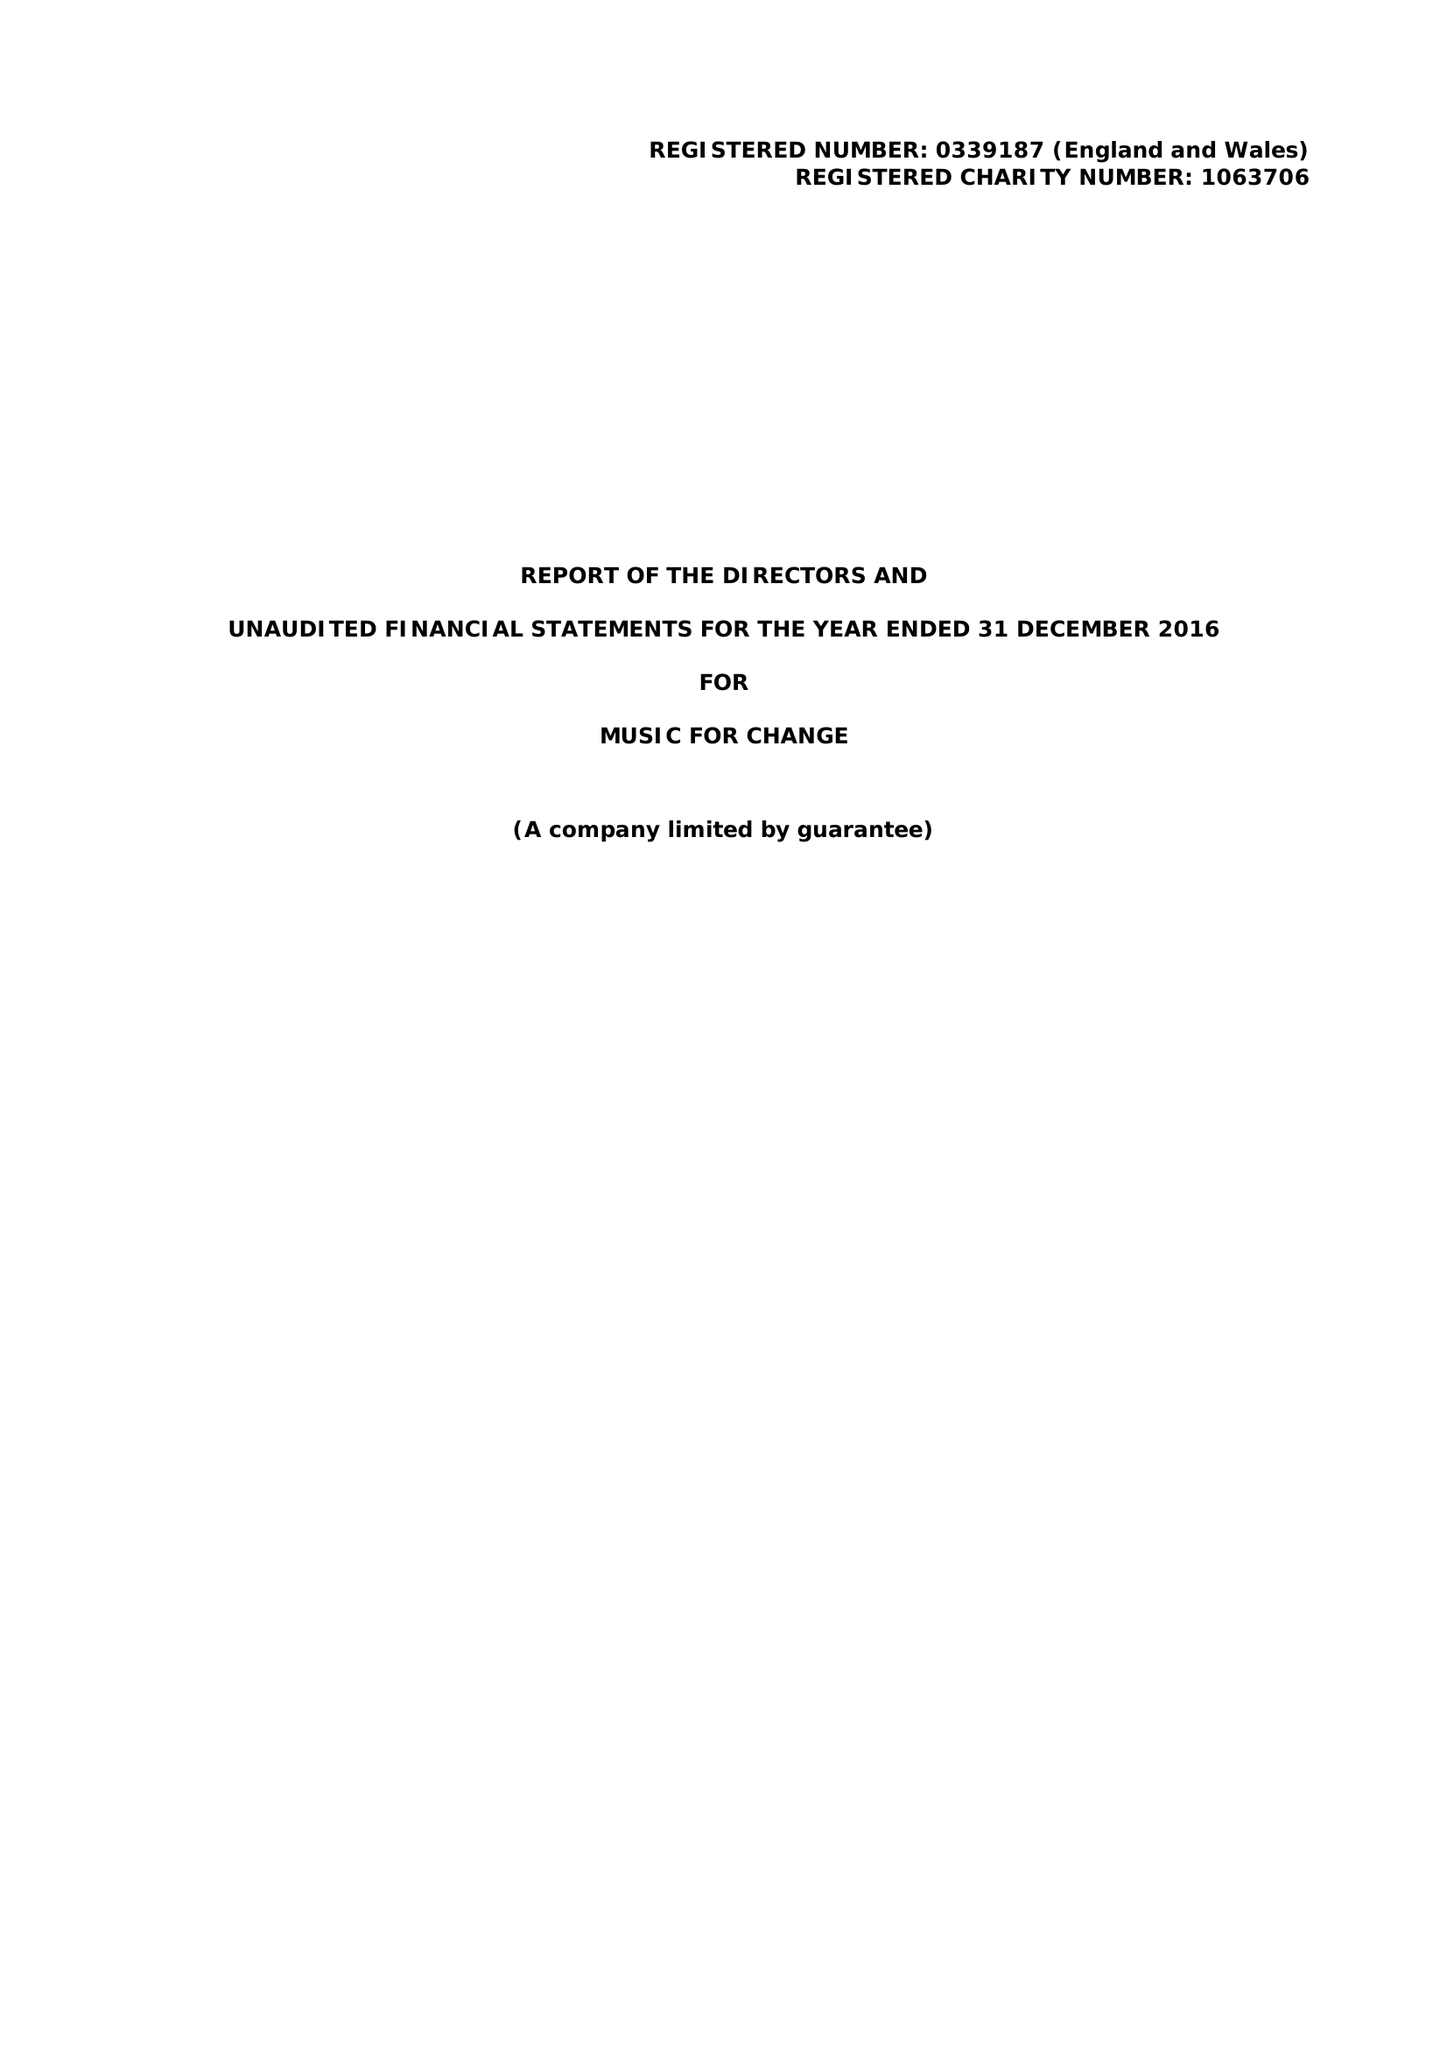What is the value for the charity_number?
Answer the question using a single word or phrase. 1063706 